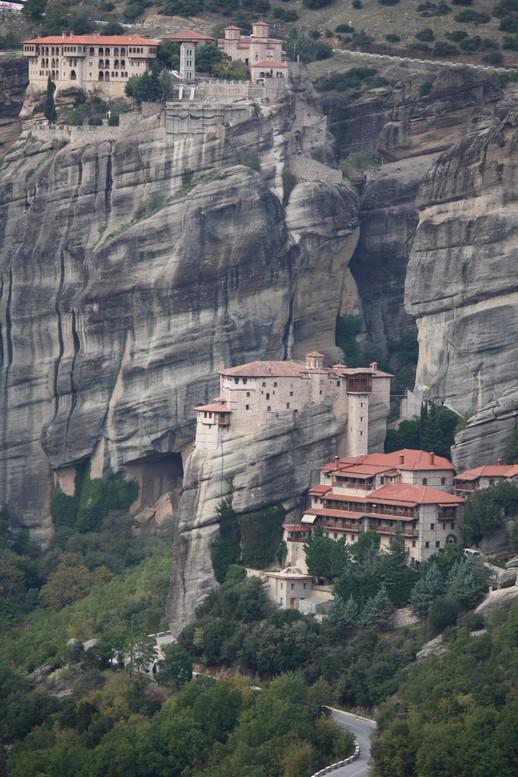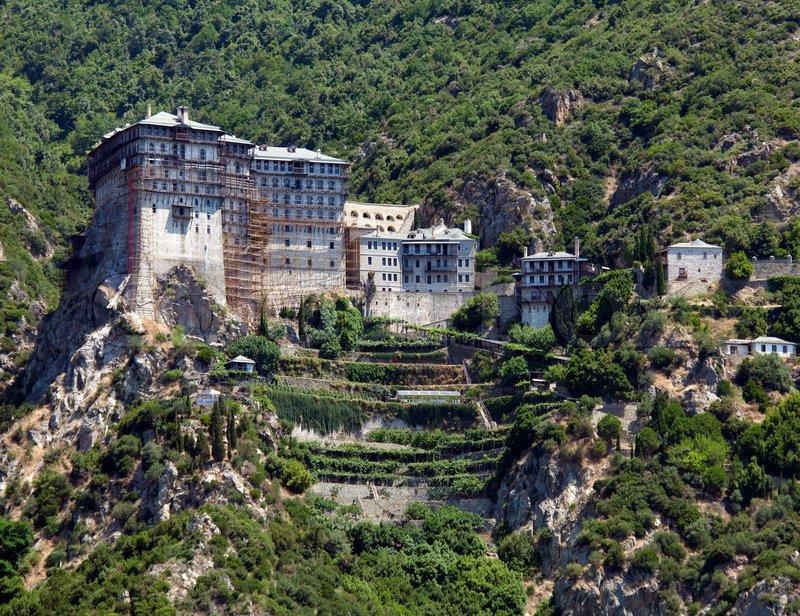The first image is the image on the left, the second image is the image on the right. Considering the images on both sides, is "Cliffs can be seen behind the castle on the left." valid? Answer yes or no. Yes. The first image is the image on the left, the second image is the image on the right. Considering the images on both sides, is "Terraced steps with greenery lead up to a series of squarish buildings with neutral-colored roofs in one image." valid? Answer yes or no. Yes. 